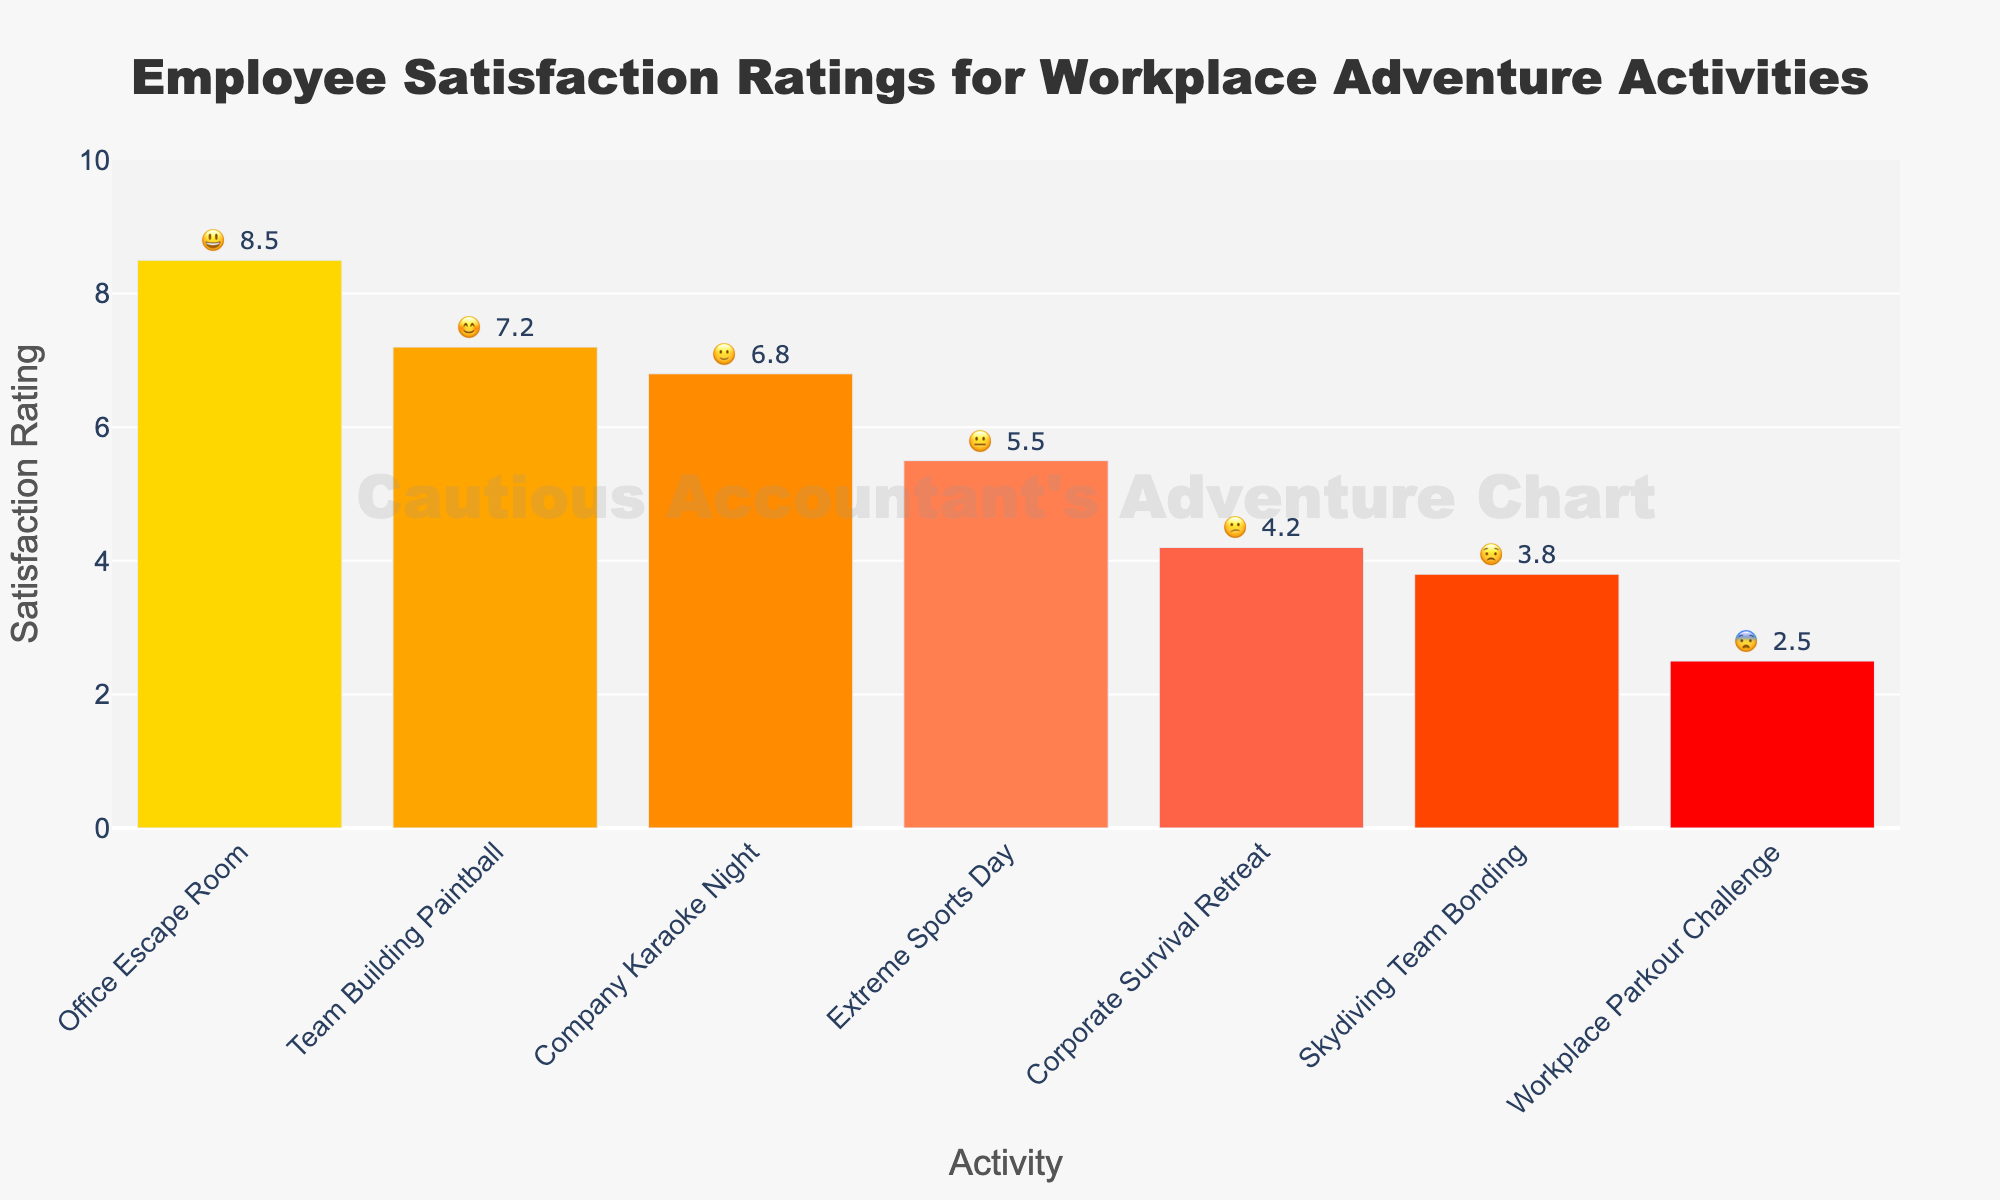What's the title of the chart? The title of the chart is written at the top and is described as "Employee Satisfaction Ratings for Workplace Adventure Activities".
Answer: Employee Satisfaction Ratings for Workplace Adventure Activities Which activity has the highest satisfaction rating and what is the rating? The activity with the highest satisfaction rating is "Office Escape Room," with a rating displayed directly above the bar as 8.5.
Answer: Office Escape Room, 8.5 What is the emoji associated with the "Corporate Survival Retreat"? The emoji associated with "Corporate Survival Retreat" is displayed next to its rating and is "😕".
Answer: 😕 How many activities have a satisfaction rating above 7? To find the number of activities above 7, count all bars with ratings higher than 7. "Office Escape Room" and "Team Building Paintball" have ratings above 7.
Answer: 2 Which activity has the lowest satisfaction rating and what emoji is used to represent it? The lowest satisfaction rating is for "Workplace Parkour Challenge", which has a rating of 2.5 as displayed directly above the bar. The emoji representing it is "😨".
Answer: Workplace Parkour Challenge, 😨 What is the average satisfaction rating for all activities? To find the average, sum all satisfaction ratings: 8.5 + 7.2 + 6.8 + 5.5 + 4.2 + 3.8 + 2.5 = 38.5. Divide by the number of activities, which is 7. So, 38.5 / 7 = 5.5.
Answer: 5.5 Which activity is rated higher, "Extreme Sports Day" or "Skydiving Team Bonding"? Compare the ratings directly above their respective bars. "Extreme Sports Day" has a rating of 5.5, whereas "Skydiving Team Bonding" has 3.8.
Answer: Extreme Sports Day How much higher is the satisfaction rating of "Office Escape Room" compared to "Company Karaoke Night"? Subtract the rating of "Company Karaoke Night" from "Office Escape Room." 8.5 (Office Escape Room) - 6.8 (Company Karaoke Night) = 1.7.
Answer: 1.7 What color represents the "Team Building Paintball" bar? The color of the bar can be observed from the visual information where "Team Building Paintball" is in the shade of a medium orange color.
Answer: Medium orange Is there any activity with a neutral emoji, and what is the activity's rating? A neutral emoji "😐" is associated with "Extreme Sports Day," whose rating is directly visible above the bar as 5.5.
Answer: 😐, 5.5 